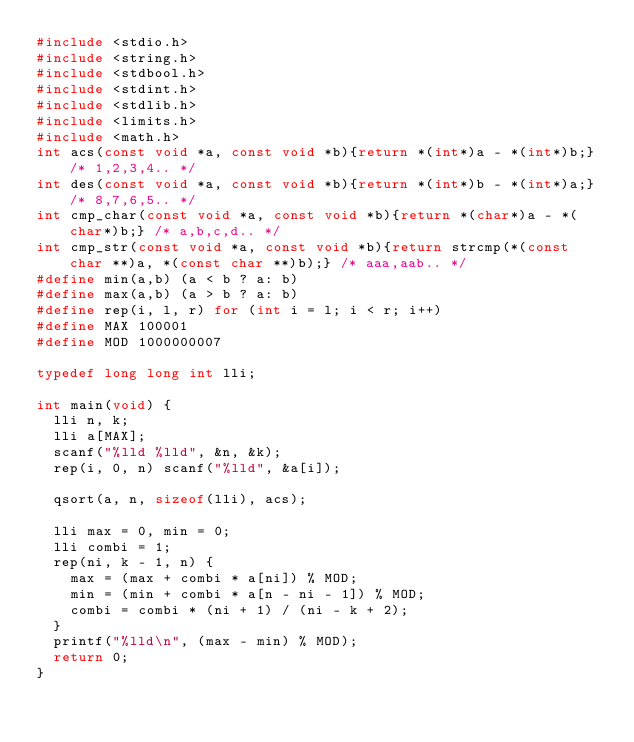Convert code to text. <code><loc_0><loc_0><loc_500><loc_500><_C_>#include <stdio.h>
#include <string.h>
#include <stdbool.h>
#include <stdint.h>
#include <stdlib.h>
#include <limits.h>
#include <math.h>
int acs(const void *a, const void *b){return *(int*)a - *(int*)b;} /* 1,2,3,4.. */
int des(const void *a, const void *b){return *(int*)b - *(int*)a;} /* 8,7,6,5.. */
int cmp_char(const void *a, const void *b){return *(char*)a - *(char*)b;} /* a,b,c,d.. */
int cmp_str(const void *a, const void *b){return strcmp(*(const char **)a, *(const char **)b);} /* aaa,aab.. */
#define min(a,b) (a < b ? a: b)
#define max(a,b) (a > b ? a: b)
#define rep(i, l, r) for (int i = l; i < r; i++)
#define MAX 100001
#define MOD 1000000007

typedef long long int lli;

int main(void) {
  lli n, k;
  lli a[MAX];
  scanf("%lld %lld", &n, &k);
  rep(i, 0, n) scanf("%lld", &a[i]);

  qsort(a, n, sizeof(lli), acs);

  lli max = 0, min = 0;
  lli combi = 1;
  rep(ni, k - 1, n) {
    max = (max + combi * a[ni]) % MOD;
    min = (min + combi * a[n - ni - 1]) % MOD;
    combi = combi * (ni + 1) / (ni - k + 2);
  }
  printf("%lld\n", (max - min) % MOD);
  return 0;
}
</code> 